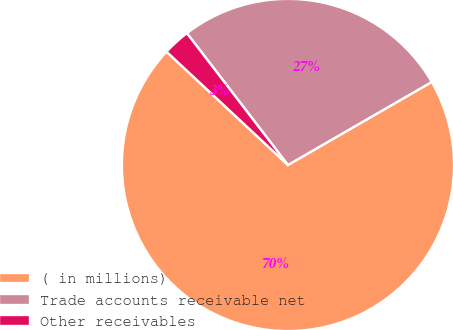Convert chart. <chart><loc_0><loc_0><loc_500><loc_500><pie_chart><fcel>( in millions)<fcel>Trade accounts receivable net<fcel>Other receivables<nl><fcel>70.29%<fcel>27.08%<fcel>2.64%<nl></chart> 